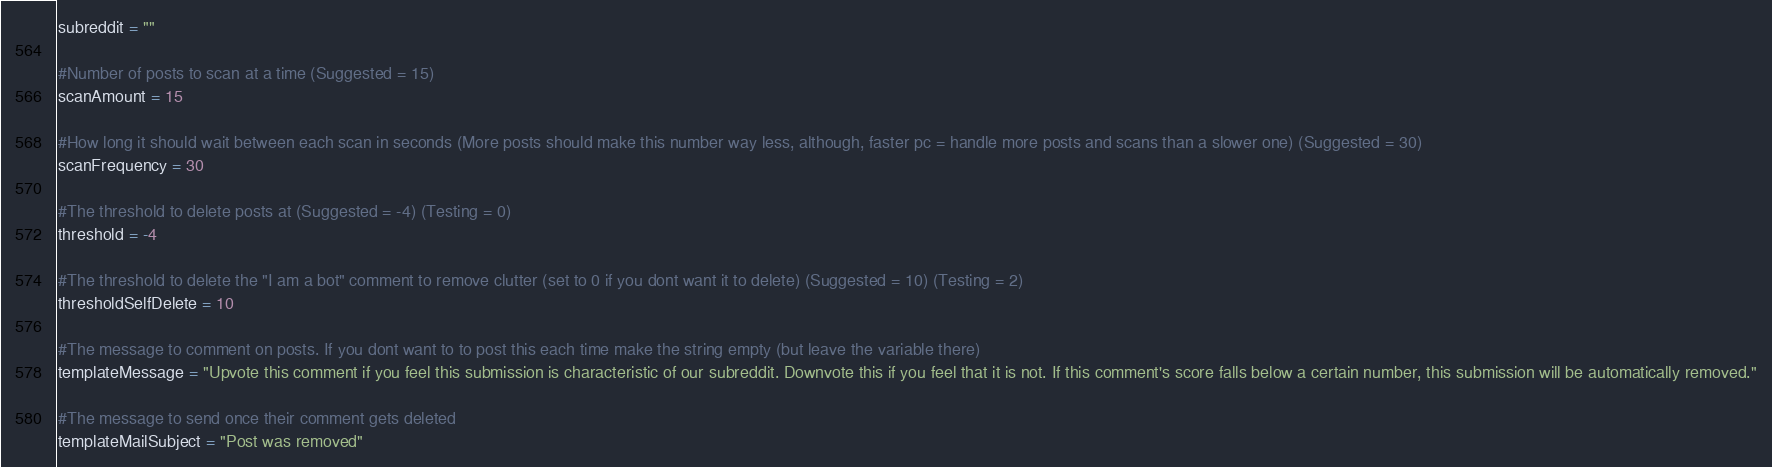<code> <loc_0><loc_0><loc_500><loc_500><_Python_>subreddit = ""

#Number of posts to scan at a time (Suggested = 15)
scanAmount = 15

#How long it should wait between each scan in seconds (More posts should make this number way less, although, faster pc = handle more posts and scans than a slower one) (Suggested = 30)
scanFrequency = 30

#The threshold to delete posts at (Suggested = -4) (Testing = 0)
threshold = -4

#The threshold to delete the "I am a bot" comment to remove clutter (set to 0 if you dont want it to delete) (Suggested = 10) (Testing = 2)
thresholdSelfDelete = 10

#The message to comment on posts. If you dont want to to post this each time make the string empty (but leave the variable there)
templateMessage = "Upvote this comment if you feel this submission is characteristic of our subreddit. Downvote this if you feel that it is not. If this comment's score falls below a certain number, this submission will be automatically removed."

#The message to send once their comment gets deleted
templateMailSubject = "Post was removed"</code> 